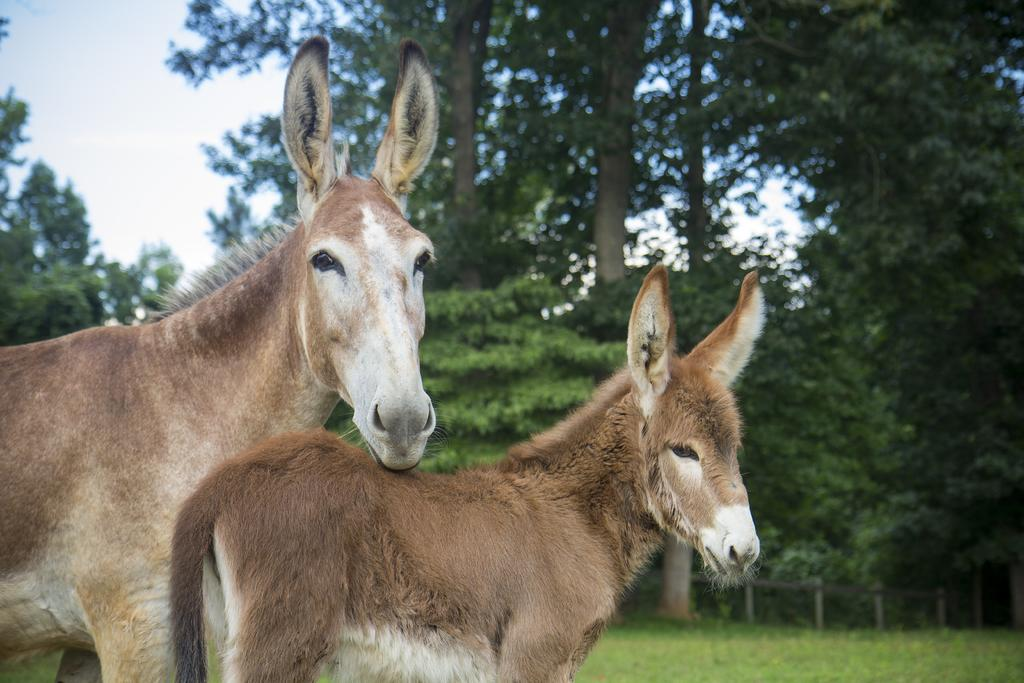What animal is the main subject of the picture? There is a donkey in the picture. Can you describe the size of the donkey? There is a small donkey in the picture. What is the position of the donkeys in the image? The donkeys are standing. What can be seen in the background of the picture? There are trees in the backdrop of the picture. How would you describe the weather based on the image? The sky is clear in the picture, suggesting good weather. Can you tell me how many snakes are wrapped around the donkey's legs in the image? There are no snakes present in the image; it features a small donkey standing with trees in the background. What type of rake is being used by the bears in the image? There are no bears or rakes present in the image; it only features a small donkey standing. 